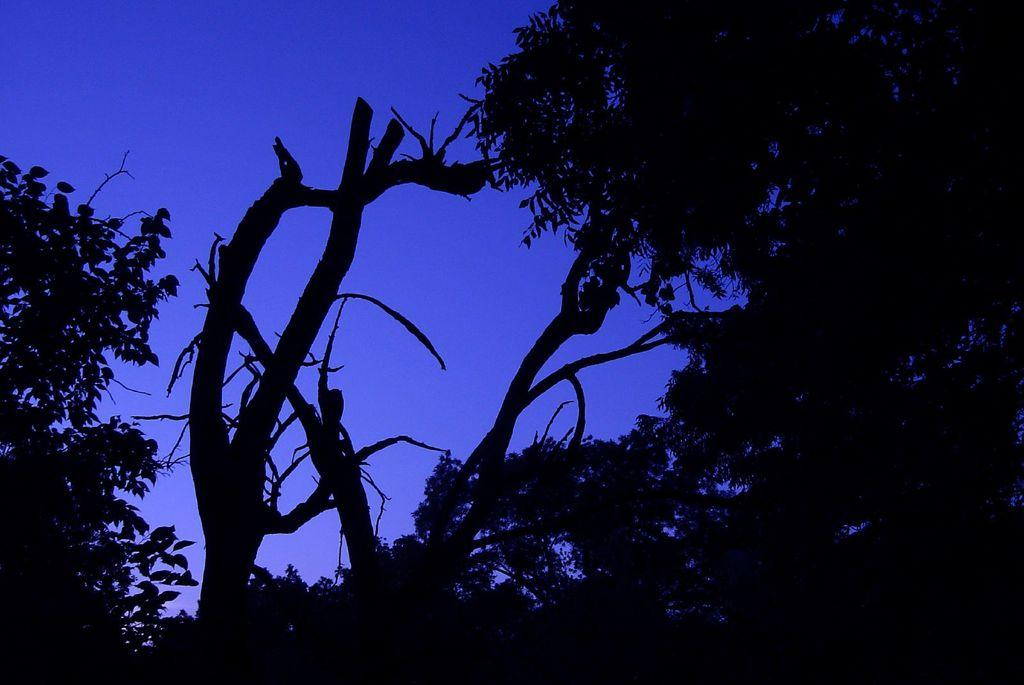What type of vegetation can be seen in the image? There are trees visible in the image. What part of the natural environment is visible in the image? The sky is visible in the background of the image. How many babies are visible in the image? There are no babies present in the image. What type of vegetable is being used as a prop in the image? There is no celery or any other vegetable present in the image. 